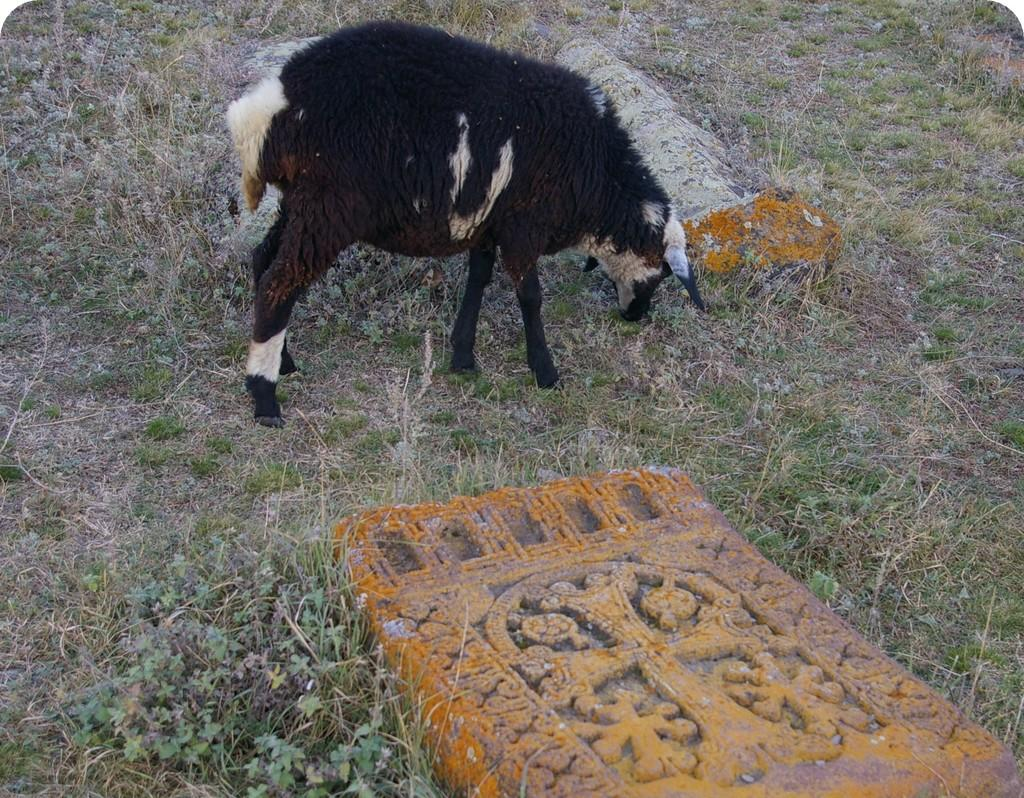What type of animal can be seen in the image? There is an animal in the image, but its specific type cannot be determined from the provided facts. What can be found in the image besides the animal? There are graves in the image. What type of vegetation is visible in the background of the image? There is grass visible in the background of the image. Where is the goose sitting in the image? There is no goose present in the image. What type of food is being served in the lunchroom in the image? There is no lunchroom present in the image. 